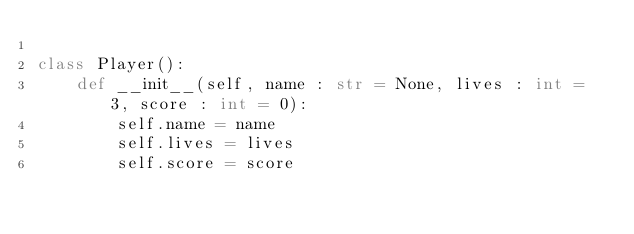<code> <loc_0><loc_0><loc_500><loc_500><_Python_>
class Player():
    def __init__(self, name : str = None, lives : int = 3, score : int = 0):
        self.name = name
        self.lives = lives
        self.score = score</code> 